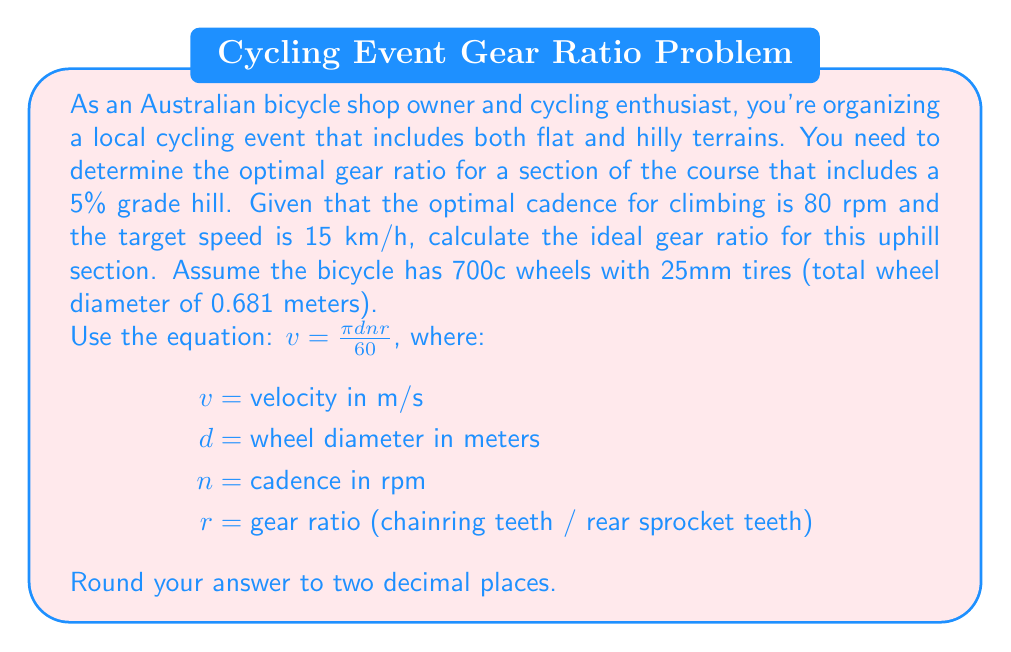Help me with this question. To solve this problem, we'll follow these steps:

1. Convert the given speed from km/h to m/s:
   $15 \text{ km/h} = 15 * \frac{1000}{3600} = 4.167 \text{ m/s}$

2. Use the given equation and solve for $r$:
   $v = \frac{\pi d n r}{60}$
   $r = \frac{60v}{\pi d n}$

3. Substitute the known values:
   $v = 4.167 \text{ m/s}$
   $d = 0.681 \text{ m}$
   $n = 80 \text{ rpm}$

4. Calculate the gear ratio:

   $$r = \frac{60 * 4.167}{\pi * 0.681 * 80}$$

   $$r = \frac{250.02}{170.96} = 1.4624$$

5. Round to two decimal places: 1.46

This gear ratio of 1.46 means that for every full rotation of the pedals, the rear wheel will rotate 1.46 times. In practical terms, this could be achieved with a chainring of 38 teeth and a rear sprocket of 26 teeth (38/26 ≈ 1.46).
Answer: The optimal gear ratio for the uphill section is 1.46. 